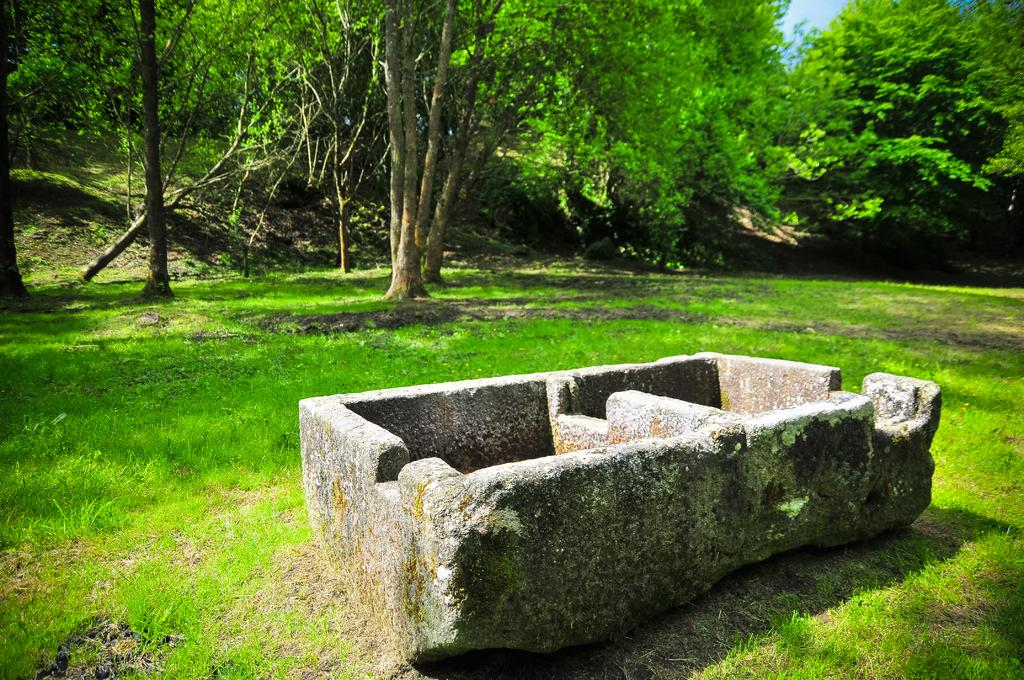What is the main object in the image? There is a tube-like object in the image. Where is the tube-like object located? The tube-like object is placed in the grass. What can be seen in the background of the image? There are trees visible in the image. What type of bird is sitting on the tube-like object in the image? There is no bird present on the tube-like object in the image. What type of oil is being extracted from the tube-like object in the image? There is no indication of oil extraction or any oil-related activity in the image. 